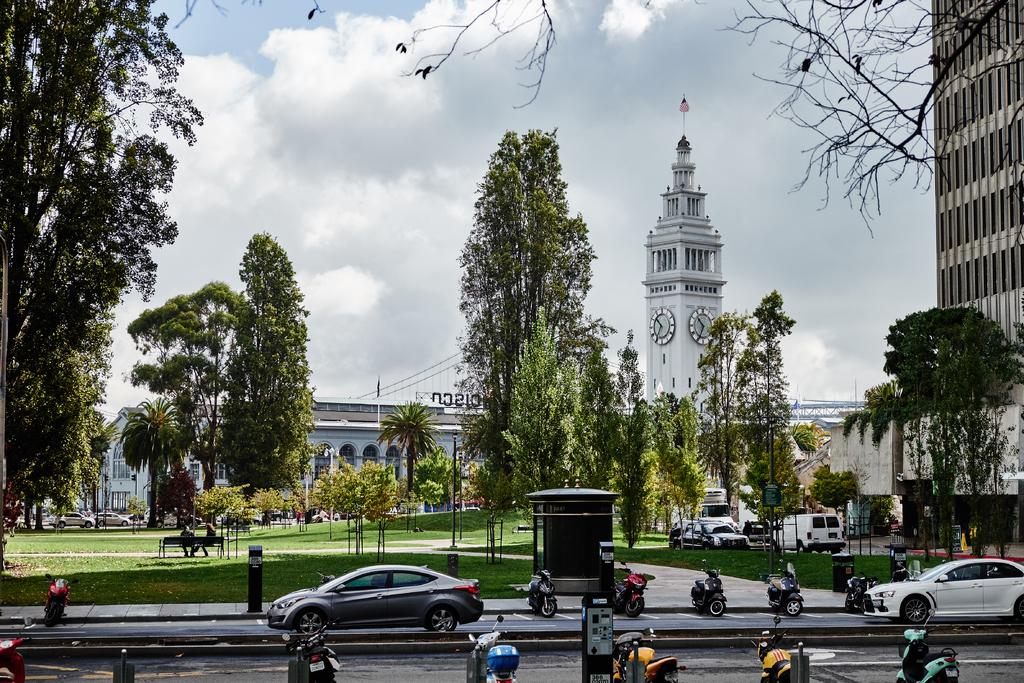What can be seen in the foreground of the image? There are vehicles on the road in the foreground of the image. What is visible in the background of the image? There are buildings and trees in the background of the image. What is visible at the top of the image? The sky is visible at the top of the image. What can be observed in the sky? Clouds are present in the sky. Can you tell me where the sofa is located in the image? There is no sofa present in the image. Are there any crimes being committed in the image? There is no indication of any crime in the image. 